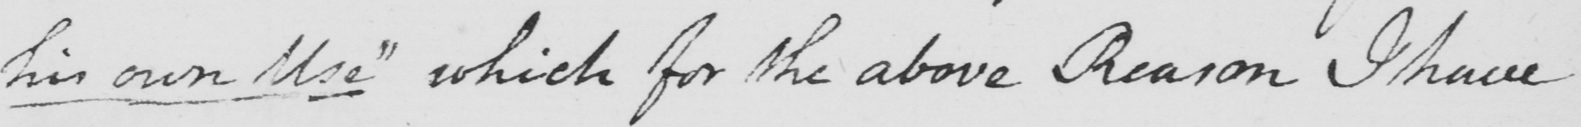What does this handwritten line say? his own use "  which for the above Reason I have 